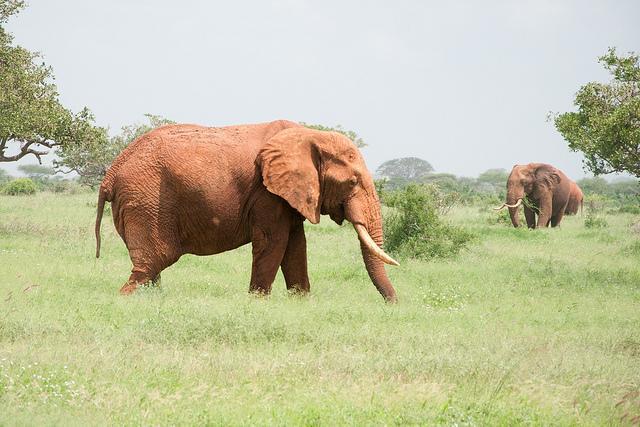How many tusk?
Give a very brief answer. 4. How many elephants?
Give a very brief answer. 2. How many elephants are there?
Give a very brief answer. 2. How many elephants are in the picture?
Give a very brief answer. 2. How many sinks are in the image?
Give a very brief answer. 0. 